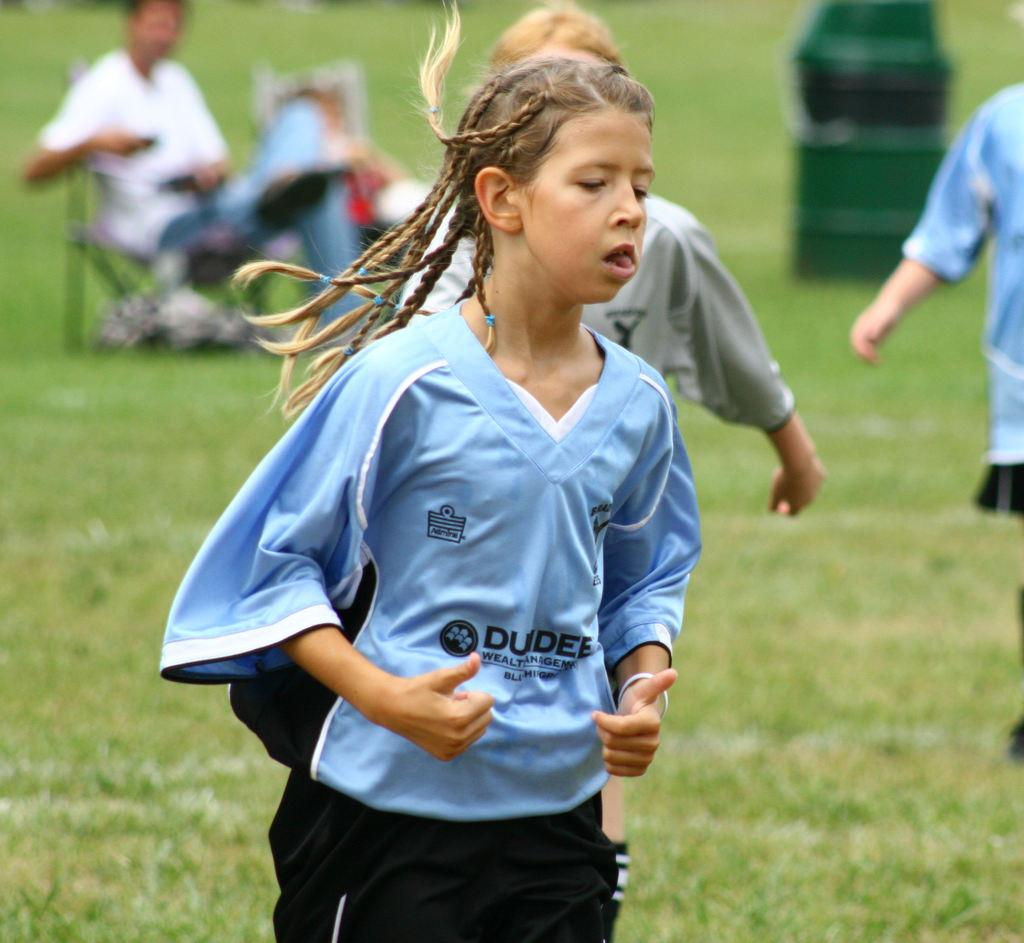Who is the main subject in the image? There is a girl in the image. What is the girl wearing? The girl is wearing a blue jersey. Can you describe the background of the image? There are people in the background of the image. What is the ground made of in the image? There is green grass on the ground in the image. What type of calculator is the girl using in the image? There is no calculator present in the image. 